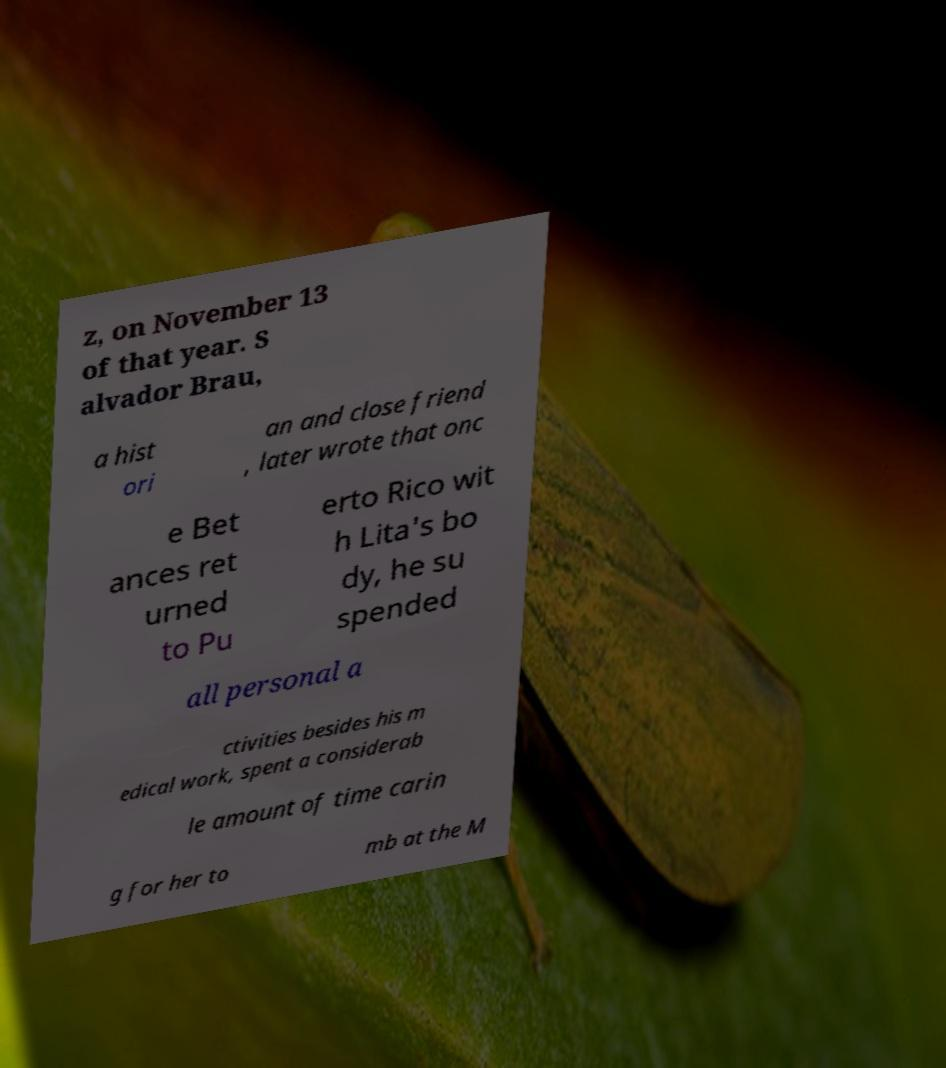Could you extract and type out the text from this image? z, on November 13 of that year. S alvador Brau, a hist ori an and close friend , later wrote that onc e Bet ances ret urned to Pu erto Rico wit h Lita's bo dy, he su spended all personal a ctivities besides his m edical work, spent a considerab le amount of time carin g for her to mb at the M 